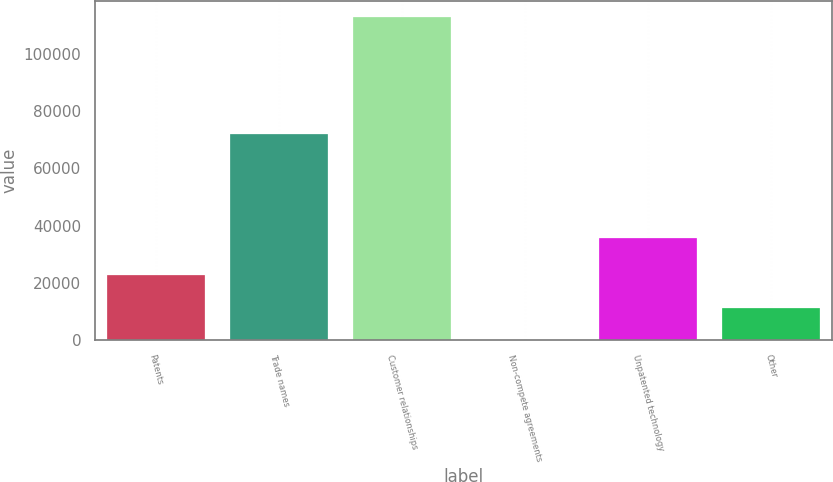Convert chart. <chart><loc_0><loc_0><loc_500><loc_500><bar_chart><fcel>Patents<fcel>Trade names<fcel>Customer relationships<fcel>Non-compete agreements<fcel>Unpatented technology<fcel>Other<nl><fcel>22602.6<fcel>71962<fcel>112937<fcel>19<fcel>35817<fcel>11310.8<nl></chart> 